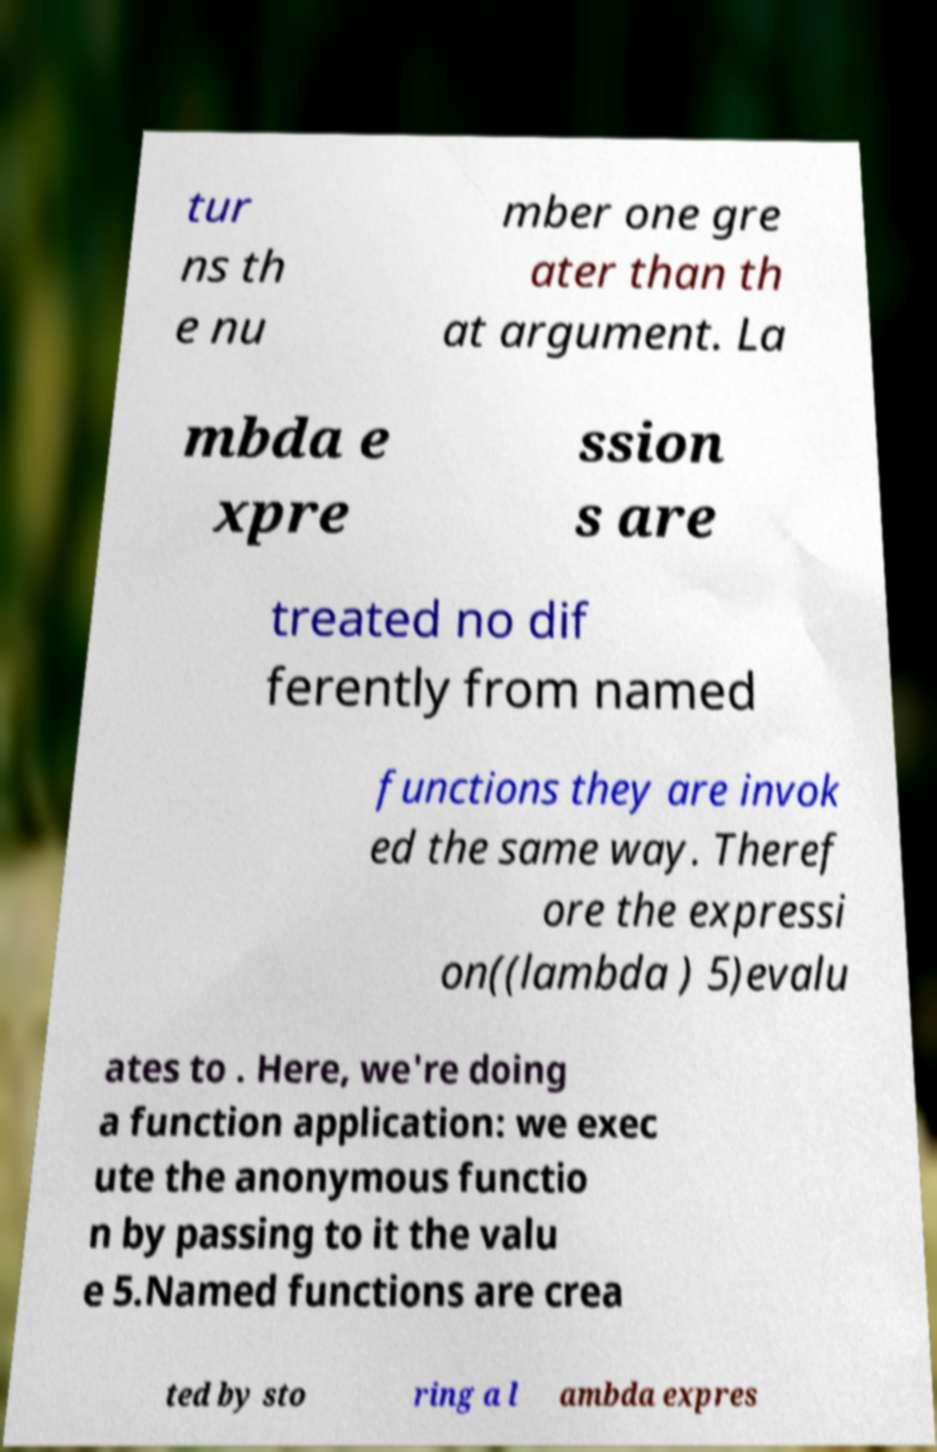For documentation purposes, I need the text within this image transcribed. Could you provide that? tur ns th e nu mber one gre ater than th at argument. La mbda e xpre ssion s are treated no dif ferently from named functions they are invok ed the same way. Theref ore the expressi on((lambda ) 5)evalu ates to . Here, we're doing a function application: we exec ute the anonymous functio n by passing to it the valu e 5.Named functions are crea ted by sto ring a l ambda expres 